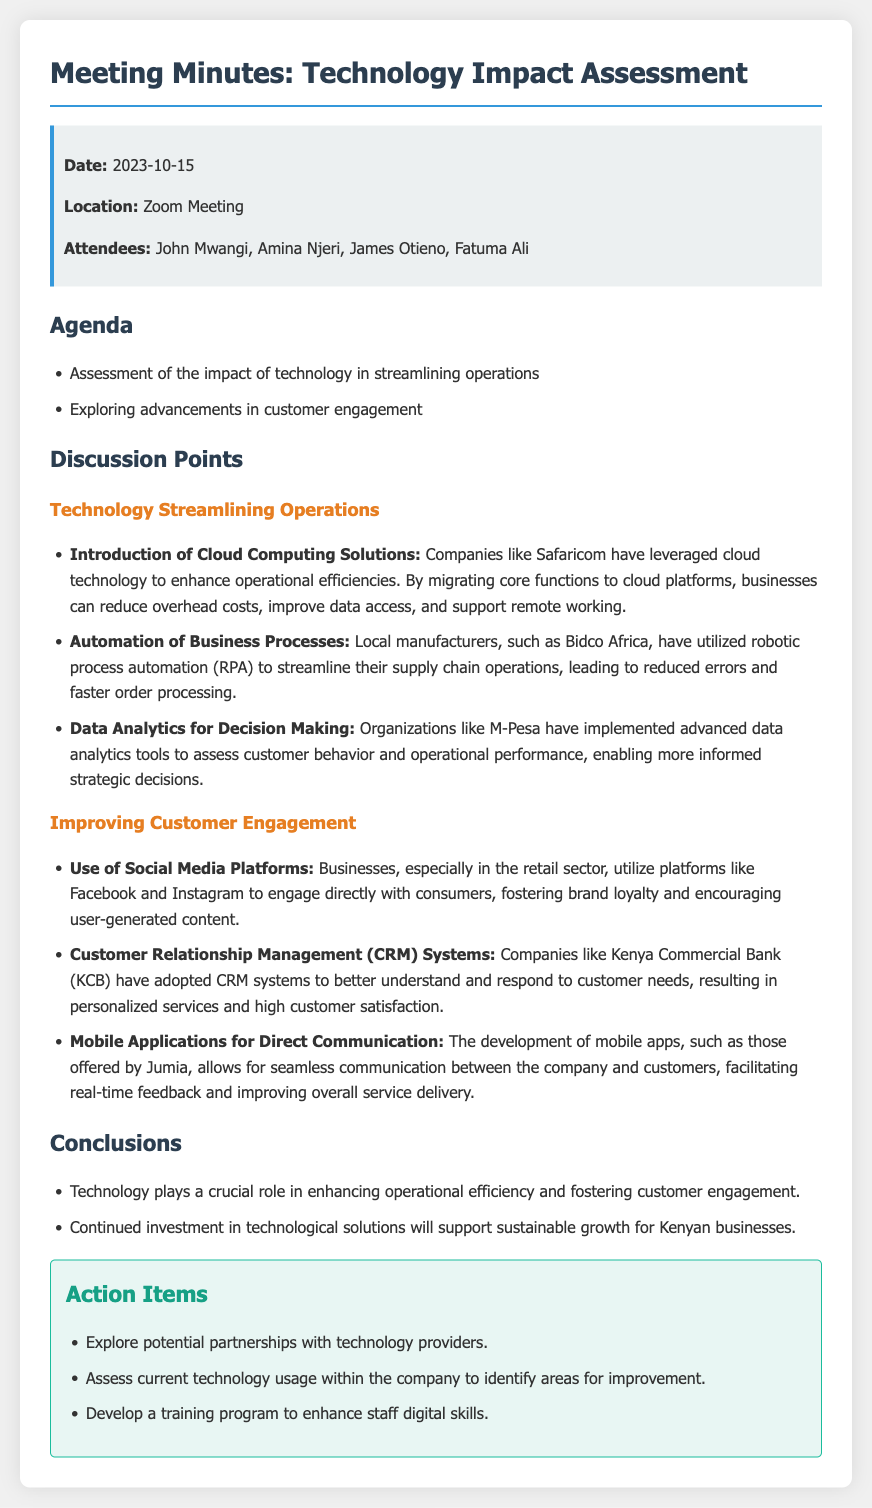What is the date of the meeting? The date of the meeting is stated in the document under the info box section.
Answer: 2023-10-15 Who are the attendees of the meeting? The attendees are listed in the info box section.
Answer: John Mwangi, Amina Njeri, James Otieno, Fatuma Ali What technology solution has Safaricom leveraged? The document mentions that Safaricom has leveraged cloud technology to enhance operational efficiencies.
Answer: Cloud Computing Solutions Which company used robotic process automation? The document states that Bidco Africa utilized robotic process automation to streamline operations.
Answer: Bidco Africa What application was mentioned for direct communication? The document references mobile apps as a means for seamless communication, specifically offered by Jumia.
Answer: Jumia What was one conclusion drawn from the meeting? Conclusions are summarized in the listed points at the end of the document.
Answer: Technology plays a crucial role in enhancing operational efficiency and fostering customer engagement What action item involves assessing technology? One of the action items explicitly mentions the assessment of current technology usage within the company.
Answer: Assess current technology usage What social media platforms are mentioned? The document discusses the use of Facebook and Instagram for engaging with consumers.
Answer: Facebook and Instagram What is the overall purpose of the meeting? The agenda clearly indicates the meeting's purpose revolves around technology impact assessment.
Answer: Assessment of the impact of technology in streamlining operations and improving customer engagement 